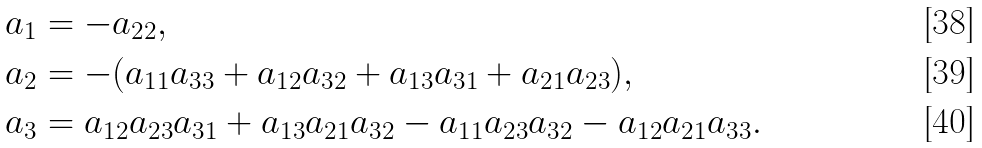<formula> <loc_0><loc_0><loc_500><loc_500>a _ { 1 } & = - a _ { 2 2 } , \\ a _ { 2 } & = - ( a _ { 1 1 } a _ { 3 3 } + a _ { 1 2 } a _ { 3 2 } + a _ { 1 3 } a _ { 3 1 } + a _ { 2 1 } a _ { 2 3 } ) , \\ a _ { 3 } & = a _ { 1 2 } a _ { 2 3 } a _ { 3 1 } + a _ { 1 3 } a _ { 2 1 } a _ { 3 2 } - a _ { 1 1 } a _ { 2 3 } a _ { 3 2 } - a _ { 1 2 } a _ { 2 1 } a _ { 3 3 } .</formula> 